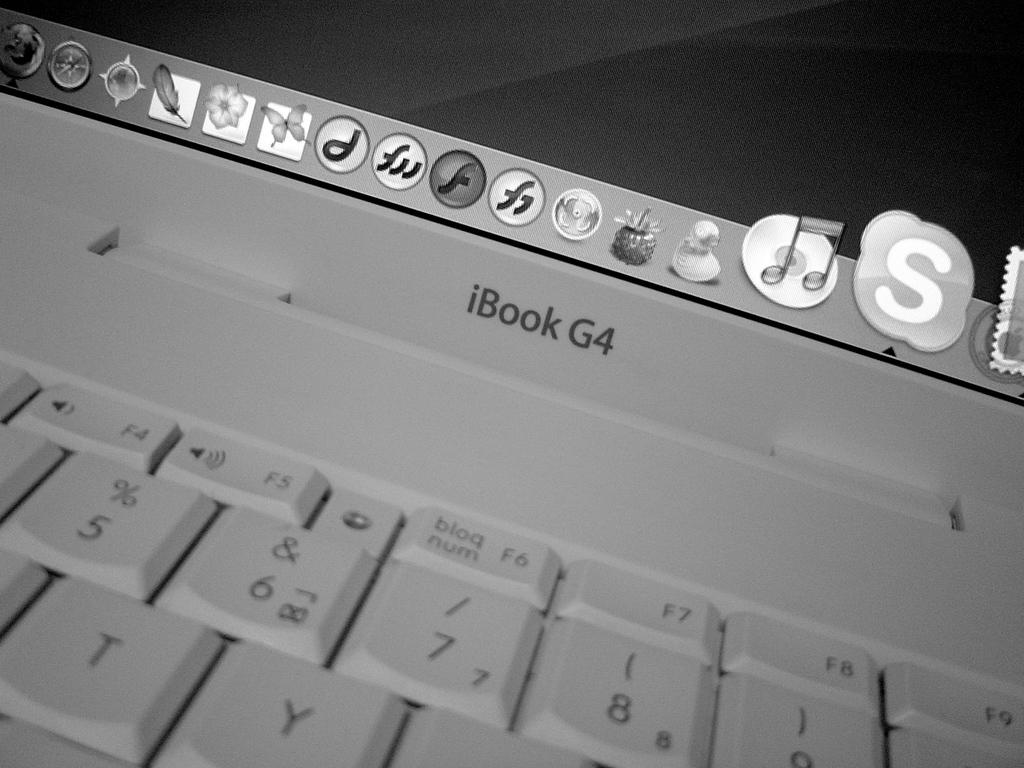<image>
Provide a brief description of the given image. A close up of a keyboard and monitor of an iBook 64 computer. 